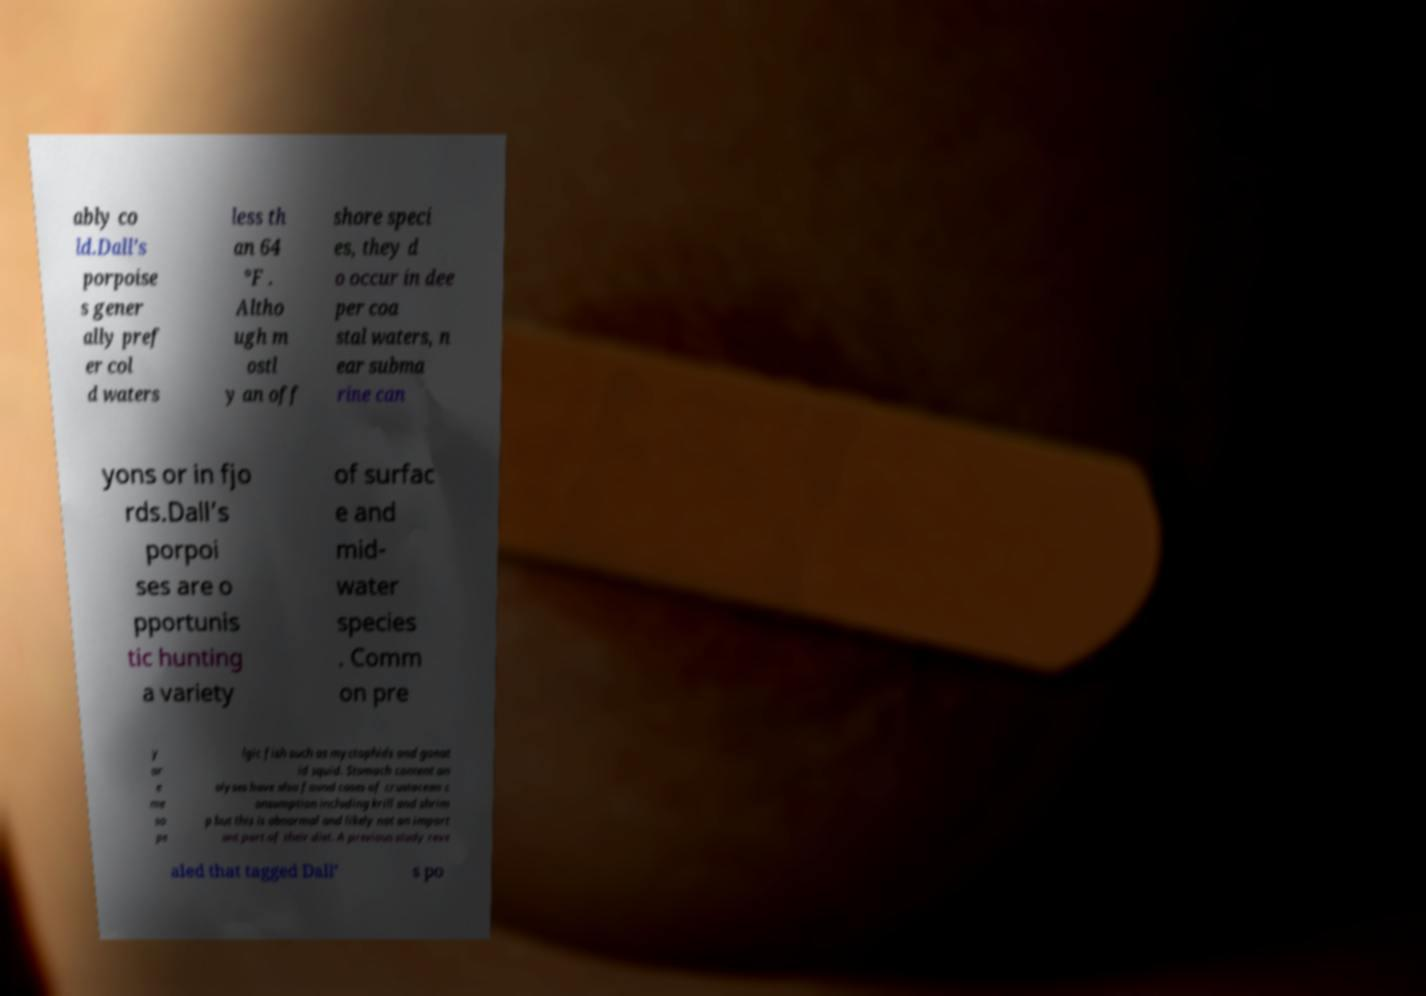Can you read and provide the text displayed in the image?This photo seems to have some interesting text. Can you extract and type it out for me? ably co ld.Dall’s porpoise s gener ally pref er col d waters less th an 64 °F . Altho ugh m ostl y an off shore speci es, they d o occur in dee per coa stal waters, n ear subma rine can yons or in fjo rds.Dall’s porpoi ses are o pportunis tic hunting a variety of surfac e and mid- water species . Comm on pre y ar e me so pe lgic fish such as myctophids and gonat id squid. Stomach content an alyses have also found cases of crustacean c onsumption including krill and shrim p but this is abnormal and likely not an import ant part of their diet. A previous study reve aled that tagged Dall’ s po 